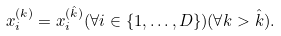<formula> <loc_0><loc_0><loc_500><loc_500>x ^ { ( k ) } _ { i } = x ^ { ( \hat { k } ) } _ { i } ( \forall i \in \{ 1 , \dots , D \} ) ( \forall k > \hat { k } ) .</formula> 